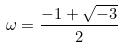<formula> <loc_0><loc_0><loc_500><loc_500>\omega = \frac { - 1 + \sqrt { - 3 } } { 2 }</formula> 